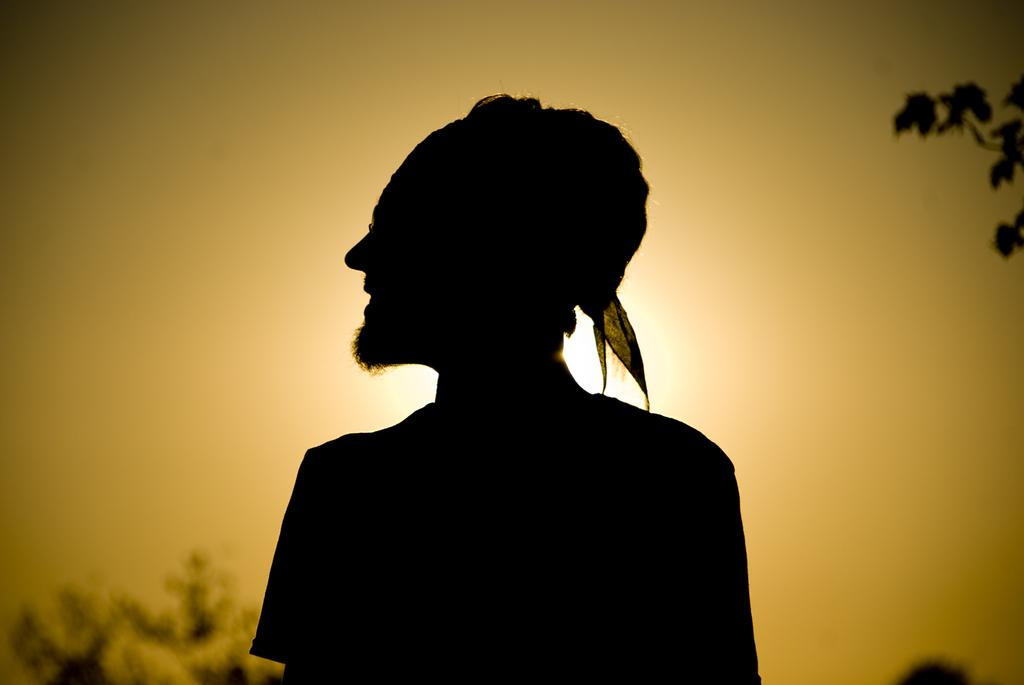What is the main subject in the foreground of the picture? There is a person standing in the foreground of the picture. What can be seen on the right side of the picture? There is a stem of a tree on the right side of the picture. What is located on the left side of the picture? There is a tree on the left side of the picture. How would you describe the weather in the image? The sky is sunny, which suggests a clear and bright day. What type of metal is used to build the person's home in the image? There is no home present in the image, and therefore no metal can be associated with it. 